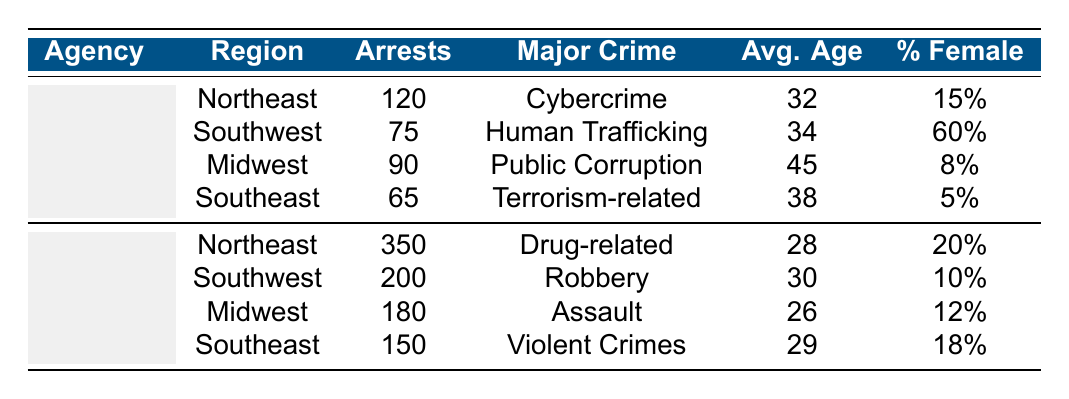What is the major crime category for the FBI in the Northeast region? The table indicates that the FBI's major crime category in the Northeast region is Cybercrime.
Answer: Cybercrime How many arrests did Local Law Enforcement make in the Southwest region? The table shows that Local Law Enforcement made 200 arrests in the Southwest region.
Answer: 200 Which agency had a higher average age of arrestees in the Midwest region? The FBI has an average age of arrestees at 45, while Local Law Enforcement has an average age of 26 in the Midwest region. Therefore, the FBI had a higher average age of arrestees.
Answer: FBI What is the total number of arrests made by the FBI across all regions? Adding the number of arrests by the FBI (120 + 75 + 90 + 65) gives a total of 350 arrests across all regions.
Answer: 350 Is the percentage of female arrestees higher for Local Law Enforcement in the Northeast compared to the FBI in the same region? The table shows Local Law Enforcement's percentage of female arrestees at 20% and the FBI's percentage at 15% in the Northeast region. Since 20% is greater than 15%, the statement is true.
Answer: Yes What is the difference in the number of arrests between the FBI and Local Law Enforcement in the Southeast region? The FBI made 65 arrests while Local Law Enforcement made 150 arrests in the Southeast region. Therefore, the difference is 150 - 65 = 85 arrests.
Answer: 85 In which region did the FBI make the least number of arrests? By checking the number of arrests made by the FBI in each region (Northeast: 120, Southwest: 75, Midwest: 90, Southeast: 65), it is clear that the Southeast region has the least number of arrests at 65.
Answer: Southeast What is the combined percentage of female arrestees for Local Law Enforcement in the Southwest and Midwest regions? The percentage of female arrestees for Local Law Enforcement in the Southwest is 10% and in the Midwest is 12%. Combining these gives 10% + 12% = 22%.
Answer: 22% Did the FBI make more arrests in the Northeast than in the Southeast? The table shows that the FBI made 120 arrests in the Northeast and 65 in the Southeast. Since 120 is greater than 65, the FBI made more arrests in the Northeast.
Answer: Yes 